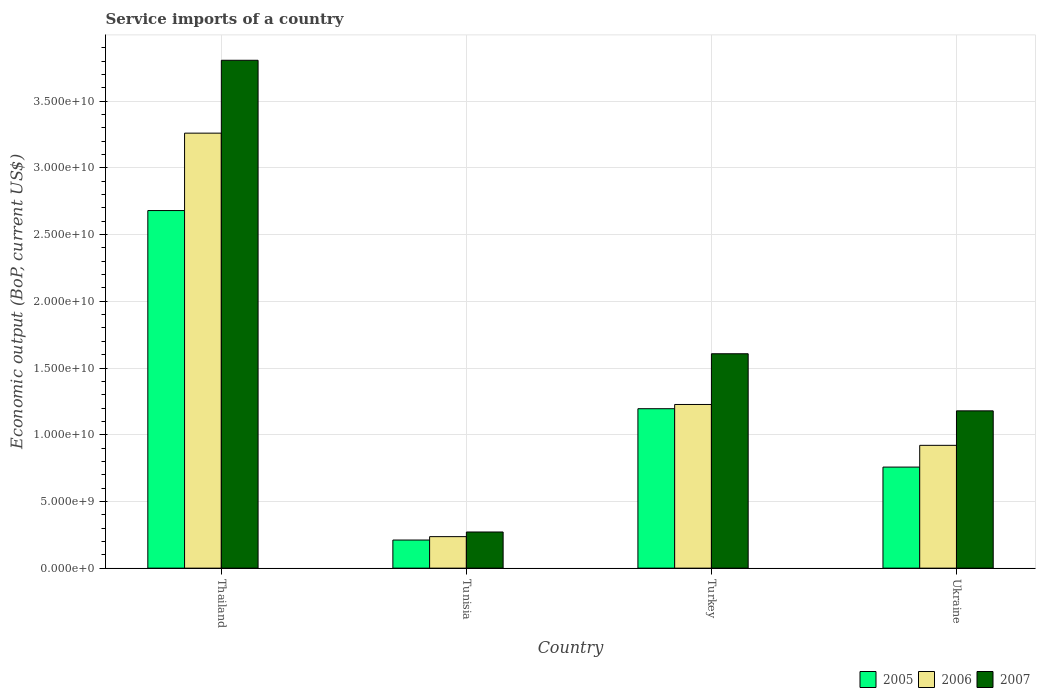How many different coloured bars are there?
Offer a terse response. 3. Are the number of bars per tick equal to the number of legend labels?
Provide a succinct answer. Yes. Are the number of bars on each tick of the X-axis equal?
Your answer should be compact. Yes. How many bars are there on the 1st tick from the left?
Your response must be concise. 3. How many bars are there on the 3rd tick from the right?
Provide a short and direct response. 3. What is the label of the 4th group of bars from the left?
Offer a terse response. Ukraine. What is the service imports in 2006 in Ukraine?
Ensure brevity in your answer.  9.20e+09. Across all countries, what is the maximum service imports in 2007?
Provide a short and direct response. 3.81e+1. Across all countries, what is the minimum service imports in 2007?
Provide a succinct answer. 2.71e+09. In which country was the service imports in 2006 maximum?
Provide a succinct answer. Thailand. In which country was the service imports in 2007 minimum?
Give a very brief answer. Tunisia. What is the total service imports in 2007 in the graph?
Give a very brief answer. 6.86e+1. What is the difference between the service imports in 2007 in Tunisia and that in Turkey?
Your response must be concise. -1.34e+1. What is the difference between the service imports in 2007 in Thailand and the service imports in 2006 in Ukraine?
Offer a very short reply. 2.89e+1. What is the average service imports in 2007 per country?
Make the answer very short. 1.72e+1. What is the difference between the service imports of/in 2006 and service imports of/in 2005 in Tunisia?
Your answer should be compact. 2.55e+08. What is the ratio of the service imports in 2007 in Thailand to that in Turkey?
Provide a succinct answer. 2.37. Is the service imports in 2005 in Thailand less than that in Tunisia?
Provide a short and direct response. No. Is the difference between the service imports in 2006 in Thailand and Tunisia greater than the difference between the service imports in 2005 in Thailand and Tunisia?
Give a very brief answer. Yes. What is the difference between the highest and the second highest service imports in 2006?
Your answer should be very brief. 3.06e+09. What is the difference between the highest and the lowest service imports in 2007?
Your answer should be very brief. 3.54e+1. What does the 2nd bar from the left in Tunisia represents?
Give a very brief answer. 2006. Are all the bars in the graph horizontal?
Offer a terse response. No. How many countries are there in the graph?
Give a very brief answer. 4. Does the graph contain any zero values?
Provide a short and direct response. No. How many legend labels are there?
Offer a very short reply. 3. How are the legend labels stacked?
Your answer should be compact. Horizontal. What is the title of the graph?
Keep it short and to the point. Service imports of a country. Does "2009" appear as one of the legend labels in the graph?
Offer a very short reply. No. What is the label or title of the Y-axis?
Provide a succinct answer. Economic output (BoP, current US$). What is the Economic output (BoP, current US$) in 2005 in Thailand?
Provide a short and direct response. 2.68e+1. What is the Economic output (BoP, current US$) of 2006 in Thailand?
Offer a terse response. 3.26e+1. What is the Economic output (BoP, current US$) in 2007 in Thailand?
Your response must be concise. 3.81e+1. What is the Economic output (BoP, current US$) in 2005 in Tunisia?
Ensure brevity in your answer.  2.11e+09. What is the Economic output (BoP, current US$) of 2006 in Tunisia?
Offer a terse response. 2.36e+09. What is the Economic output (BoP, current US$) of 2007 in Tunisia?
Provide a succinct answer. 2.71e+09. What is the Economic output (BoP, current US$) in 2005 in Turkey?
Offer a terse response. 1.20e+1. What is the Economic output (BoP, current US$) of 2006 in Turkey?
Offer a terse response. 1.23e+1. What is the Economic output (BoP, current US$) in 2007 in Turkey?
Give a very brief answer. 1.61e+1. What is the Economic output (BoP, current US$) in 2005 in Ukraine?
Give a very brief answer. 7.58e+09. What is the Economic output (BoP, current US$) of 2006 in Ukraine?
Offer a terse response. 9.20e+09. What is the Economic output (BoP, current US$) in 2007 in Ukraine?
Make the answer very short. 1.18e+1. Across all countries, what is the maximum Economic output (BoP, current US$) of 2005?
Your response must be concise. 2.68e+1. Across all countries, what is the maximum Economic output (BoP, current US$) in 2006?
Offer a very short reply. 3.26e+1. Across all countries, what is the maximum Economic output (BoP, current US$) of 2007?
Provide a succinct answer. 3.81e+1. Across all countries, what is the minimum Economic output (BoP, current US$) in 2005?
Give a very brief answer. 2.11e+09. Across all countries, what is the minimum Economic output (BoP, current US$) of 2006?
Make the answer very short. 2.36e+09. Across all countries, what is the minimum Economic output (BoP, current US$) of 2007?
Keep it short and to the point. 2.71e+09. What is the total Economic output (BoP, current US$) of 2005 in the graph?
Make the answer very short. 4.84e+1. What is the total Economic output (BoP, current US$) of 2006 in the graph?
Provide a succinct answer. 5.64e+1. What is the total Economic output (BoP, current US$) in 2007 in the graph?
Keep it short and to the point. 6.86e+1. What is the difference between the Economic output (BoP, current US$) in 2005 in Thailand and that in Tunisia?
Offer a terse response. 2.47e+1. What is the difference between the Economic output (BoP, current US$) in 2006 in Thailand and that in Tunisia?
Your answer should be very brief. 3.02e+1. What is the difference between the Economic output (BoP, current US$) of 2007 in Thailand and that in Tunisia?
Give a very brief answer. 3.54e+1. What is the difference between the Economic output (BoP, current US$) in 2005 in Thailand and that in Turkey?
Offer a terse response. 1.49e+1. What is the difference between the Economic output (BoP, current US$) in 2006 in Thailand and that in Turkey?
Offer a terse response. 2.03e+1. What is the difference between the Economic output (BoP, current US$) of 2007 in Thailand and that in Turkey?
Offer a very short reply. 2.20e+1. What is the difference between the Economic output (BoP, current US$) of 2005 in Thailand and that in Ukraine?
Keep it short and to the point. 1.92e+1. What is the difference between the Economic output (BoP, current US$) of 2006 in Thailand and that in Ukraine?
Provide a short and direct response. 2.34e+1. What is the difference between the Economic output (BoP, current US$) in 2007 in Thailand and that in Ukraine?
Keep it short and to the point. 2.63e+1. What is the difference between the Economic output (BoP, current US$) of 2005 in Tunisia and that in Turkey?
Ensure brevity in your answer.  -9.84e+09. What is the difference between the Economic output (BoP, current US$) in 2006 in Tunisia and that in Turkey?
Your response must be concise. -9.91e+09. What is the difference between the Economic output (BoP, current US$) in 2007 in Tunisia and that in Turkey?
Give a very brief answer. -1.34e+1. What is the difference between the Economic output (BoP, current US$) of 2005 in Tunisia and that in Ukraine?
Your answer should be very brief. -5.47e+09. What is the difference between the Economic output (BoP, current US$) in 2006 in Tunisia and that in Ukraine?
Your answer should be very brief. -6.84e+09. What is the difference between the Economic output (BoP, current US$) in 2007 in Tunisia and that in Ukraine?
Keep it short and to the point. -9.08e+09. What is the difference between the Economic output (BoP, current US$) in 2005 in Turkey and that in Ukraine?
Offer a terse response. 4.38e+09. What is the difference between the Economic output (BoP, current US$) in 2006 in Turkey and that in Ukraine?
Ensure brevity in your answer.  3.06e+09. What is the difference between the Economic output (BoP, current US$) of 2007 in Turkey and that in Ukraine?
Offer a very short reply. 4.28e+09. What is the difference between the Economic output (BoP, current US$) in 2005 in Thailand and the Economic output (BoP, current US$) in 2006 in Tunisia?
Offer a very short reply. 2.44e+1. What is the difference between the Economic output (BoP, current US$) of 2005 in Thailand and the Economic output (BoP, current US$) of 2007 in Tunisia?
Give a very brief answer. 2.41e+1. What is the difference between the Economic output (BoP, current US$) in 2006 in Thailand and the Economic output (BoP, current US$) in 2007 in Tunisia?
Your answer should be compact. 2.99e+1. What is the difference between the Economic output (BoP, current US$) in 2005 in Thailand and the Economic output (BoP, current US$) in 2006 in Turkey?
Provide a short and direct response. 1.45e+1. What is the difference between the Economic output (BoP, current US$) in 2005 in Thailand and the Economic output (BoP, current US$) in 2007 in Turkey?
Your answer should be compact. 1.07e+1. What is the difference between the Economic output (BoP, current US$) in 2006 in Thailand and the Economic output (BoP, current US$) in 2007 in Turkey?
Your response must be concise. 1.65e+1. What is the difference between the Economic output (BoP, current US$) of 2005 in Thailand and the Economic output (BoP, current US$) of 2006 in Ukraine?
Give a very brief answer. 1.76e+1. What is the difference between the Economic output (BoP, current US$) of 2005 in Thailand and the Economic output (BoP, current US$) of 2007 in Ukraine?
Offer a very short reply. 1.50e+1. What is the difference between the Economic output (BoP, current US$) of 2006 in Thailand and the Economic output (BoP, current US$) of 2007 in Ukraine?
Make the answer very short. 2.08e+1. What is the difference between the Economic output (BoP, current US$) of 2005 in Tunisia and the Economic output (BoP, current US$) of 2006 in Turkey?
Make the answer very short. -1.02e+1. What is the difference between the Economic output (BoP, current US$) of 2005 in Tunisia and the Economic output (BoP, current US$) of 2007 in Turkey?
Offer a terse response. -1.40e+1. What is the difference between the Economic output (BoP, current US$) in 2006 in Tunisia and the Economic output (BoP, current US$) in 2007 in Turkey?
Offer a very short reply. -1.37e+1. What is the difference between the Economic output (BoP, current US$) of 2005 in Tunisia and the Economic output (BoP, current US$) of 2006 in Ukraine?
Your response must be concise. -7.10e+09. What is the difference between the Economic output (BoP, current US$) of 2005 in Tunisia and the Economic output (BoP, current US$) of 2007 in Ukraine?
Give a very brief answer. -9.68e+09. What is the difference between the Economic output (BoP, current US$) of 2006 in Tunisia and the Economic output (BoP, current US$) of 2007 in Ukraine?
Offer a terse response. -9.43e+09. What is the difference between the Economic output (BoP, current US$) of 2005 in Turkey and the Economic output (BoP, current US$) of 2006 in Ukraine?
Provide a succinct answer. 2.74e+09. What is the difference between the Economic output (BoP, current US$) of 2005 in Turkey and the Economic output (BoP, current US$) of 2007 in Ukraine?
Keep it short and to the point. 1.60e+08. What is the difference between the Economic output (BoP, current US$) in 2006 in Turkey and the Economic output (BoP, current US$) in 2007 in Ukraine?
Offer a very short reply. 4.78e+08. What is the average Economic output (BoP, current US$) of 2005 per country?
Provide a succinct answer. 1.21e+1. What is the average Economic output (BoP, current US$) in 2006 per country?
Ensure brevity in your answer.  1.41e+1. What is the average Economic output (BoP, current US$) of 2007 per country?
Offer a very short reply. 1.72e+1. What is the difference between the Economic output (BoP, current US$) in 2005 and Economic output (BoP, current US$) in 2006 in Thailand?
Keep it short and to the point. -5.80e+09. What is the difference between the Economic output (BoP, current US$) in 2005 and Economic output (BoP, current US$) in 2007 in Thailand?
Offer a very short reply. -1.13e+1. What is the difference between the Economic output (BoP, current US$) of 2006 and Economic output (BoP, current US$) of 2007 in Thailand?
Provide a succinct answer. -5.46e+09. What is the difference between the Economic output (BoP, current US$) in 2005 and Economic output (BoP, current US$) in 2006 in Tunisia?
Make the answer very short. -2.55e+08. What is the difference between the Economic output (BoP, current US$) of 2005 and Economic output (BoP, current US$) of 2007 in Tunisia?
Provide a succinct answer. -6.03e+08. What is the difference between the Economic output (BoP, current US$) in 2006 and Economic output (BoP, current US$) in 2007 in Tunisia?
Offer a very short reply. -3.48e+08. What is the difference between the Economic output (BoP, current US$) in 2005 and Economic output (BoP, current US$) in 2006 in Turkey?
Your response must be concise. -3.18e+08. What is the difference between the Economic output (BoP, current US$) of 2005 and Economic output (BoP, current US$) of 2007 in Turkey?
Offer a very short reply. -4.12e+09. What is the difference between the Economic output (BoP, current US$) in 2006 and Economic output (BoP, current US$) in 2007 in Turkey?
Give a very brief answer. -3.80e+09. What is the difference between the Economic output (BoP, current US$) of 2005 and Economic output (BoP, current US$) of 2006 in Ukraine?
Your response must be concise. -1.63e+09. What is the difference between the Economic output (BoP, current US$) in 2005 and Economic output (BoP, current US$) in 2007 in Ukraine?
Provide a short and direct response. -4.22e+09. What is the difference between the Economic output (BoP, current US$) in 2006 and Economic output (BoP, current US$) in 2007 in Ukraine?
Offer a very short reply. -2.58e+09. What is the ratio of the Economic output (BoP, current US$) in 2005 in Thailand to that in Tunisia?
Provide a short and direct response. 12.72. What is the ratio of the Economic output (BoP, current US$) of 2006 in Thailand to that in Tunisia?
Make the answer very short. 13.8. What is the ratio of the Economic output (BoP, current US$) of 2007 in Thailand to that in Tunisia?
Ensure brevity in your answer.  14.05. What is the ratio of the Economic output (BoP, current US$) of 2005 in Thailand to that in Turkey?
Give a very brief answer. 2.24. What is the ratio of the Economic output (BoP, current US$) in 2006 in Thailand to that in Turkey?
Your answer should be very brief. 2.66. What is the ratio of the Economic output (BoP, current US$) in 2007 in Thailand to that in Turkey?
Your answer should be very brief. 2.37. What is the ratio of the Economic output (BoP, current US$) of 2005 in Thailand to that in Ukraine?
Offer a very short reply. 3.54. What is the ratio of the Economic output (BoP, current US$) of 2006 in Thailand to that in Ukraine?
Give a very brief answer. 3.54. What is the ratio of the Economic output (BoP, current US$) of 2007 in Thailand to that in Ukraine?
Your answer should be compact. 3.23. What is the ratio of the Economic output (BoP, current US$) of 2005 in Tunisia to that in Turkey?
Offer a very short reply. 0.18. What is the ratio of the Economic output (BoP, current US$) of 2006 in Tunisia to that in Turkey?
Your answer should be compact. 0.19. What is the ratio of the Economic output (BoP, current US$) of 2007 in Tunisia to that in Turkey?
Provide a succinct answer. 0.17. What is the ratio of the Economic output (BoP, current US$) of 2005 in Tunisia to that in Ukraine?
Offer a terse response. 0.28. What is the ratio of the Economic output (BoP, current US$) in 2006 in Tunisia to that in Ukraine?
Give a very brief answer. 0.26. What is the ratio of the Economic output (BoP, current US$) of 2007 in Tunisia to that in Ukraine?
Provide a succinct answer. 0.23. What is the ratio of the Economic output (BoP, current US$) in 2005 in Turkey to that in Ukraine?
Provide a short and direct response. 1.58. What is the ratio of the Economic output (BoP, current US$) in 2006 in Turkey to that in Ukraine?
Keep it short and to the point. 1.33. What is the ratio of the Economic output (BoP, current US$) of 2007 in Turkey to that in Ukraine?
Provide a succinct answer. 1.36. What is the difference between the highest and the second highest Economic output (BoP, current US$) of 2005?
Your answer should be compact. 1.49e+1. What is the difference between the highest and the second highest Economic output (BoP, current US$) in 2006?
Your response must be concise. 2.03e+1. What is the difference between the highest and the second highest Economic output (BoP, current US$) of 2007?
Give a very brief answer. 2.20e+1. What is the difference between the highest and the lowest Economic output (BoP, current US$) of 2005?
Give a very brief answer. 2.47e+1. What is the difference between the highest and the lowest Economic output (BoP, current US$) in 2006?
Keep it short and to the point. 3.02e+1. What is the difference between the highest and the lowest Economic output (BoP, current US$) in 2007?
Keep it short and to the point. 3.54e+1. 